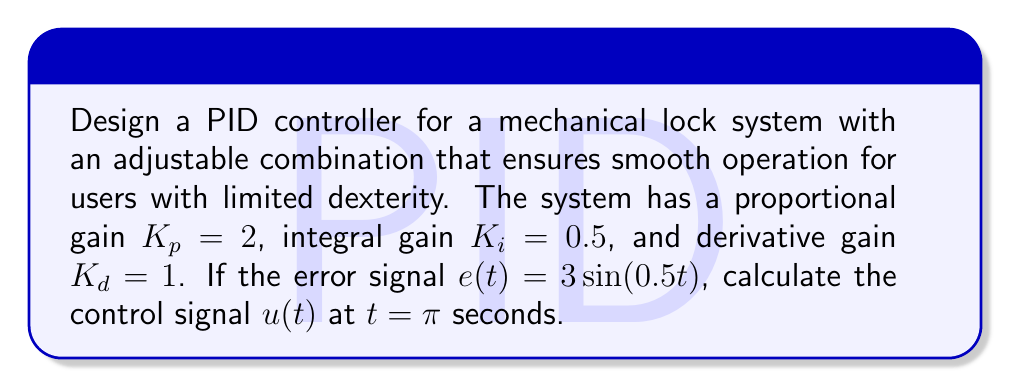Give your solution to this math problem. To solve this problem, we'll follow these steps:

1) The general form of a PID controller is:

   $$u(t) = K_p e(t) + K_i \int_0^t e(\tau) d\tau + K_d \frac{de(t)}{dt}$$

2) Given: $K_p = 2$, $K_i = 0.5$, $K_d = 1$, and $e(t) = 3\sin(0.5t)$

3) Let's calculate each term separately:

   a) Proportional term: $K_p e(t) = 2 \cdot 3\sin(0.5t) = 6\sin(0.5t)$

   b) Integral term: 
      $$K_i \int_0^t e(\tau) d\tau = 0.5 \int_0^t 3\sin(0.5\tau) d\tau$$
      $$= 1.5 \int_0^t \sin(0.5\tau) d\tau = -3\cos(0.5\tau)|_0^t$$
      $$= -3[\cos(0.5t) - 1]$$

   c) Derivative term:
      $$K_d \frac{de(t)}{dt} = 1 \cdot \frac{d}{dt}[3\sin(0.5t)] = 1.5\cos(0.5t)$$

4) Combining all terms:
   $$u(t) = 6\sin(0.5t) - 3[\cos(0.5t) - 1] + 1.5\cos(0.5t)$$
   $$= 6\sin(0.5t) - 1.5\cos(0.5t) + 3$$

5) At $t = \pi$:
   $$u(\pi) = 6\sin(0.5\pi) - 1.5\cos(0.5\pi) + 3$$
   $$= 6 - 1.5 \cdot 0 + 3 = 9$$

This control signal ensures smooth operation of the lock, accommodating the needs of users with limited dexterity.
Answer: $u(\pi) = 9$ 